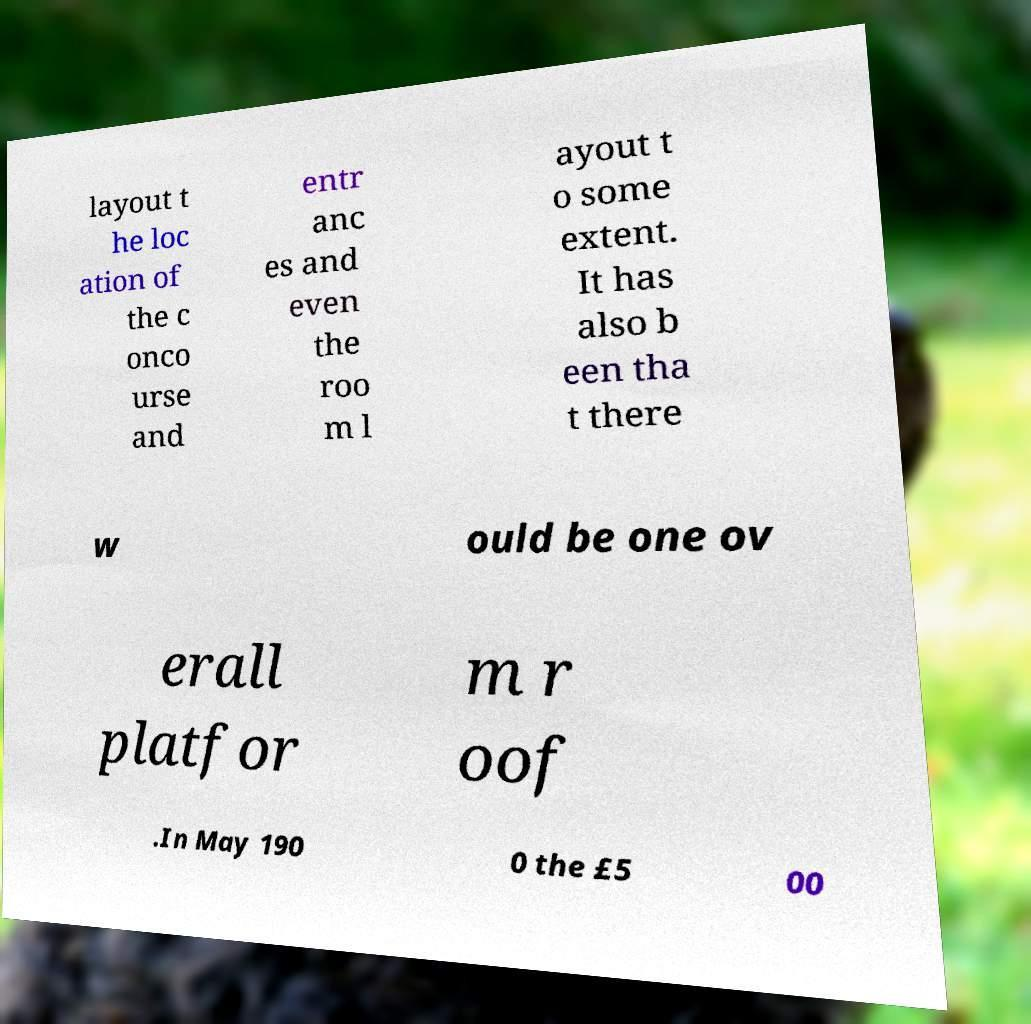I need the written content from this picture converted into text. Can you do that? layout t he loc ation of the c onco urse and entr anc es and even the roo m l ayout t o some extent. It has also b een tha t there w ould be one ov erall platfor m r oof .In May 190 0 the £5 00 